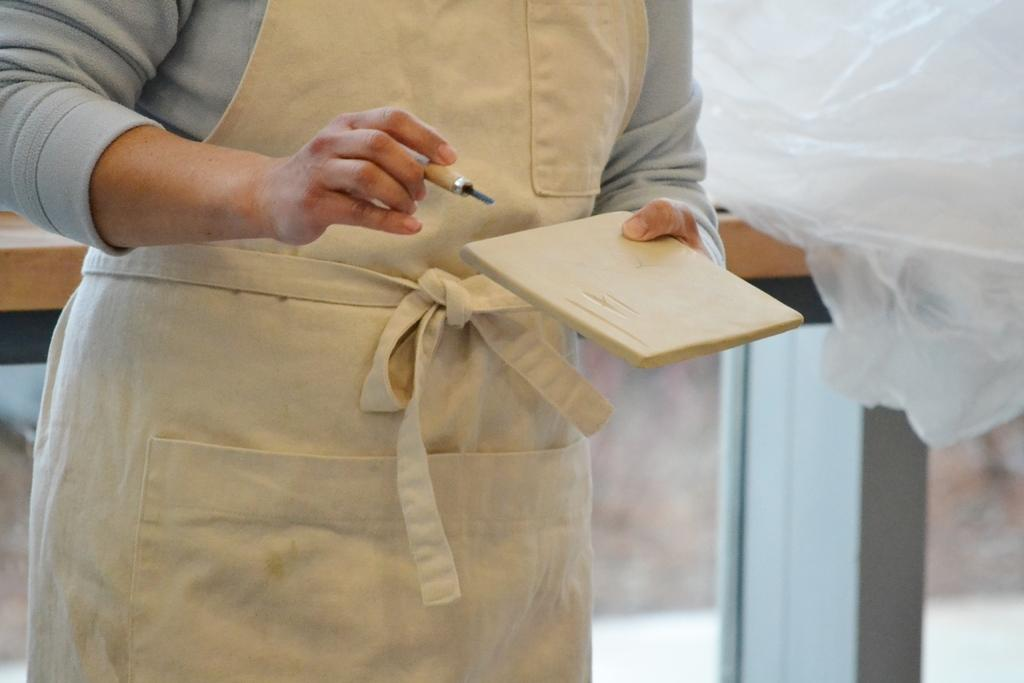What is the main subject of the image? There is a person in the image. What is the person holding in their hands? The person is holding a tool in one hand and a stone in the other hand. What can be seen in the background of the image? There is a cover and a wooden table in the background of the image. What type of island can be seen in the background of the image? There is no island present in the image; it only features a person, a tool, a stone, a cover, and a wooden table. 